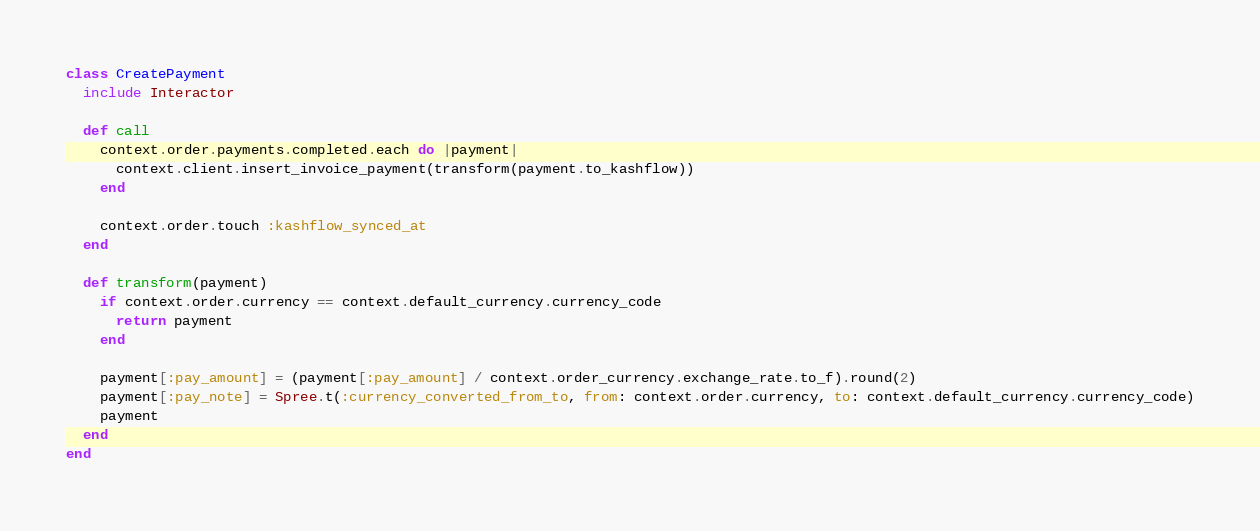<code> <loc_0><loc_0><loc_500><loc_500><_Ruby_>class CreatePayment
  include Interactor

  def call
    context.order.payments.completed.each do |payment|
      context.client.insert_invoice_payment(transform(payment.to_kashflow))
    end

    context.order.touch :kashflow_synced_at
  end

  def transform(payment)
    if context.order.currency == context.default_currency.currency_code
      return payment
    end

    payment[:pay_amount] = (payment[:pay_amount] / context.order_currency.exchange_rate.to_f).round(2)
    payment[:pay_note] = Spree.t(:currency_converted_from_to, from: context.order.currency, to: context.default_currency.currency_code)
    payment
  end
end
</code> 